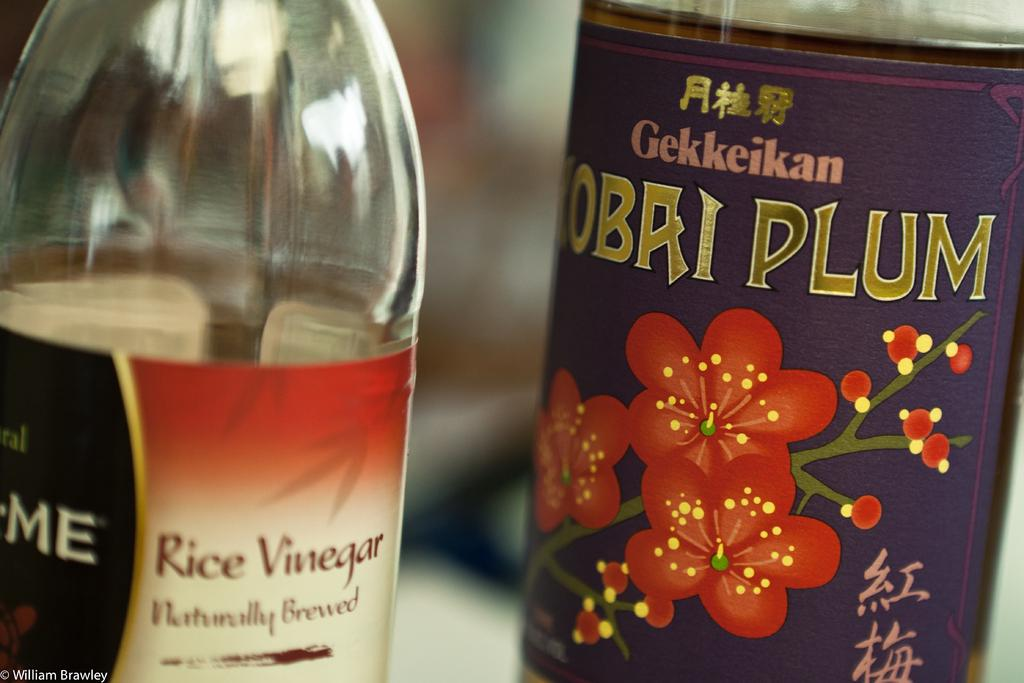<image>
Share a concise interpretation of the image provided. A dark colored bottle with red flowers next to a clear bottle with a label that says rice vinegar on it. 